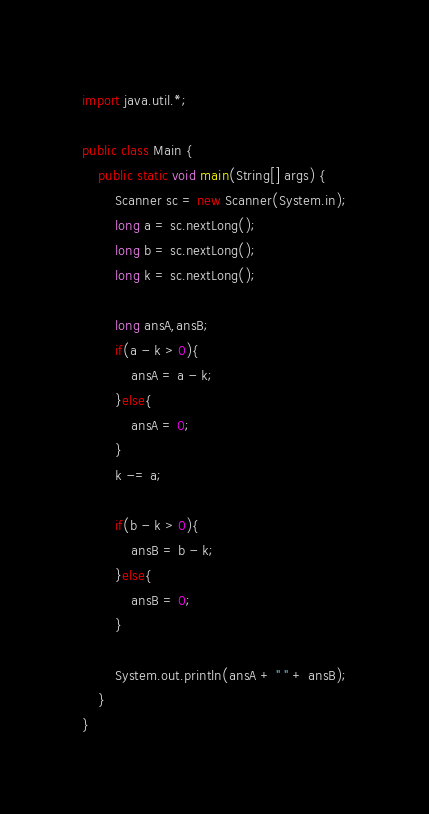Convert code to text. <code><loc_0><loc_0><loc_500><loc_500><_Java_>import java.util.*;

public class Main {
    public static void main(String[] args) {
        Scanner sc = new Scanner(System.in);
        long a = sc.nextLong();
        long b = sc.nextLong();
        long k = sc.nextLong();

        long ansA,ansB;
        if(a - k > 0){
            ansA = a - k;
        }else{
            ansA = 0;
        }
        k -= a;

        if(b - k > 0){
            ansB = b - k;
        }else{
            ansB = 0;
        }

        System.out.println(ansA + " " + ansB);
    }
}</code> 